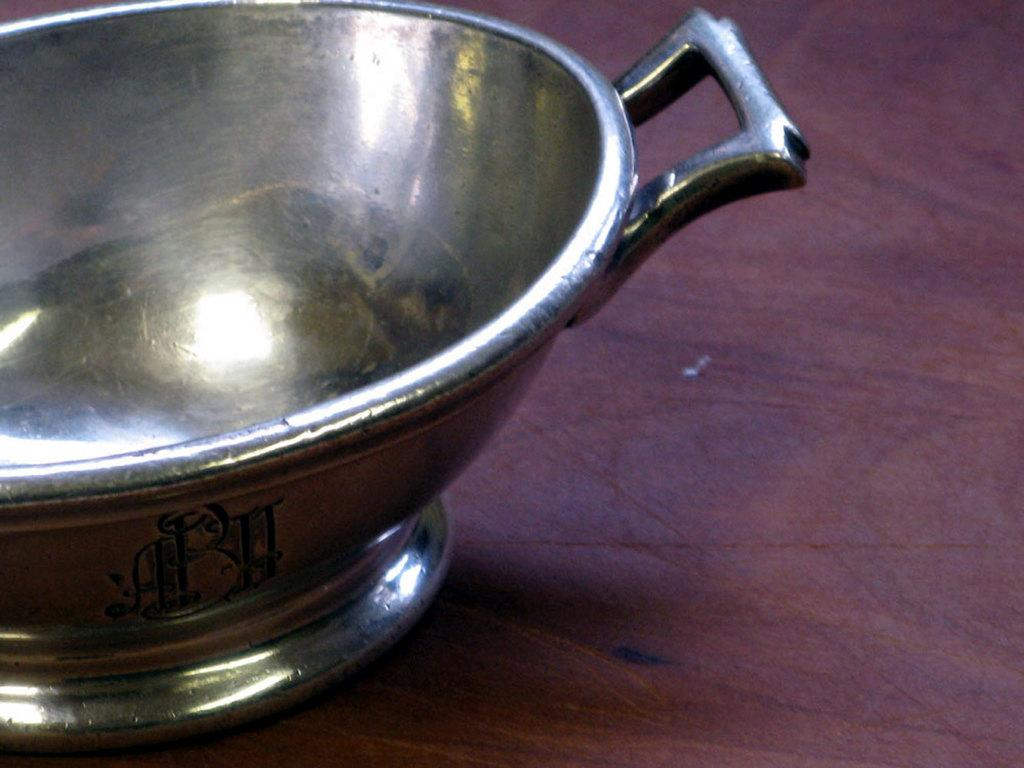What type of bowl is in the image? There is a metal bowl in the image. What color is the metal bowl? The bowl is silver in color. What is the bowl placed on? The bowl is on a pink colored surface. Are there any markings or text on the bowl? Yes, there are letters written on the bowl. What color are the letters on the bowl? The letters are written in black color. Can you see any children playing in the park in the image? There is no park or children playing in the image; it only features a metal bowl on a pink surface with letters written on it. 